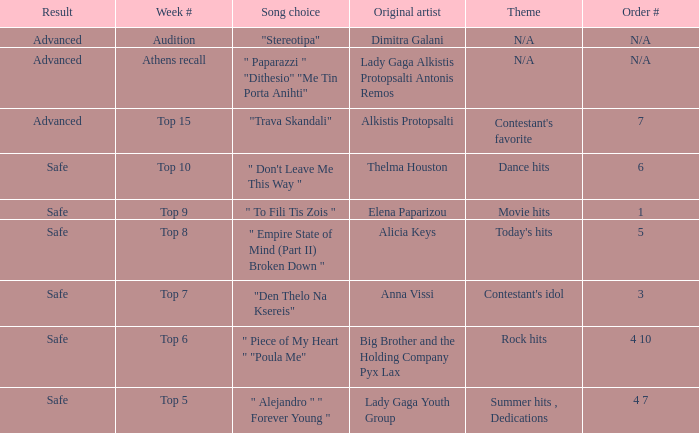Which artists have order number 6? Thelma Houston. 